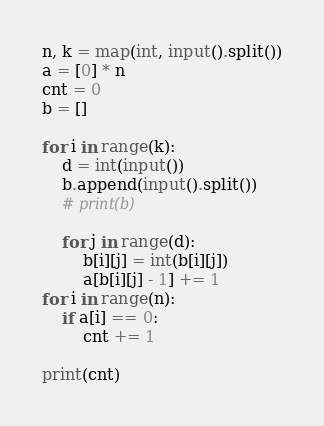<code> <loc_0><loc_0><loc_500><loc_500><_Python_>n, k = map(int, input().split())
a = [0] * n
cnt = 0
b = []

for i in range(k):
    d = int(input())
    b.append(input().split())
    # print(b)

    for j in range(d):
        b[i][j] = int(b[i][j])
        a[b[i][j] - 1] += 1
for i in range(n):
    if a[i] == 0:
        cnt += 1

print(cnt)</code> 